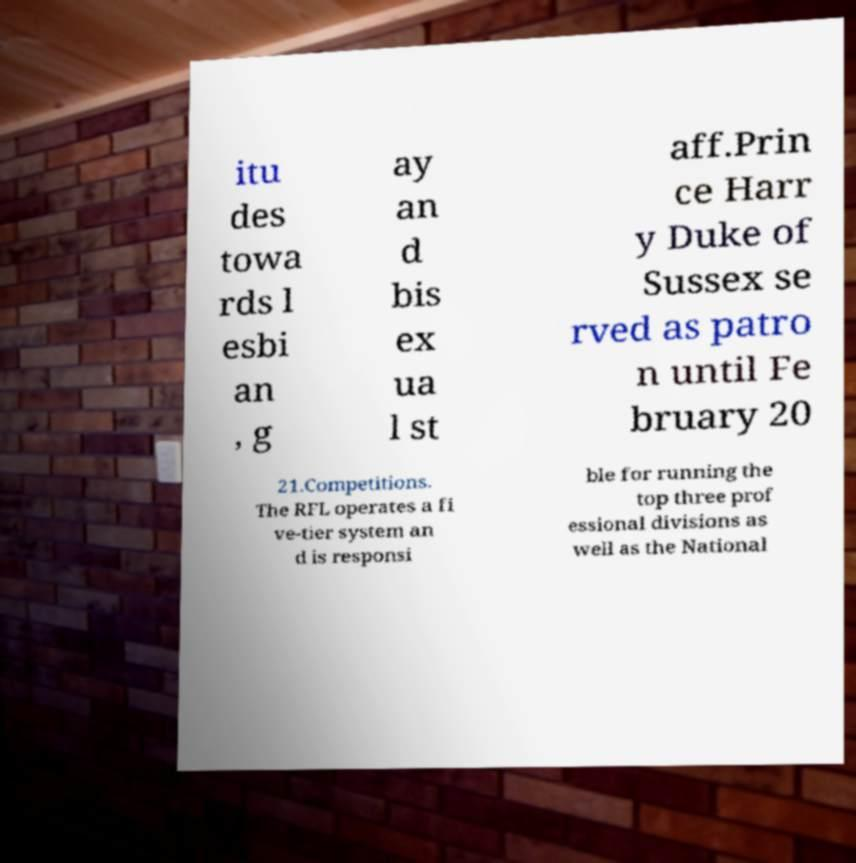For documentation purposes, I need the text within this image transcribed. Could you provide that? itu des towa rds l esbi an , g ay an d bis ex ua l st aff.Prin ce Harr y Duke of Sussex se rved as patro n until Fe bruary 20 21.Competitions. The RFL operates a fi ve-tier system an d is responsi ble for running the top three prof essional divisions as well as the National 